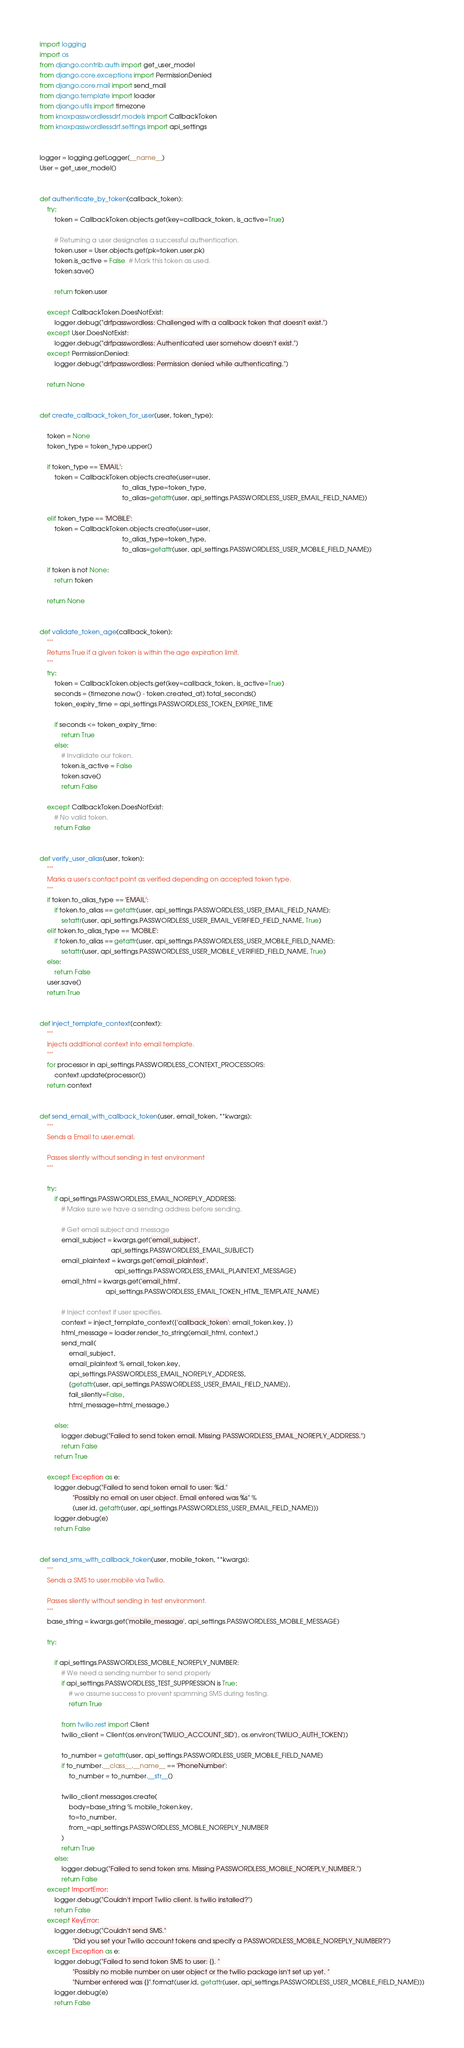Convert code to text. <code><loc_0><loc_0><loc_500><loc_500><_Python_>import logging
import os
from django.contrib.auth import get_user_model
from django.core.exceptions import PermissionDenied
from django.core.mail import send_mail
from django.template import loader
from django.utils import timezone
from knoxpasswordlessdrf.models import CallbackToken
from knoxpasswordlessdrf.settings import api_settings


logger = logging.getLogger(__name__)
User = get_user_model()


def authenticate_by_token(callback_token):
    try:
        token = CallbackToken.objects.get(key=callback_token, is_active=True)

        # Returning a user designates a successful authentication.
        token.user = User.objects.get(pk=token.user.pk)
        token.is_active = False  # Mark this token as used.
        token.save()

        return token.user

    except CallbackToken.DoesNotExist:
        logger.debug("drfpasswordless: Challenged with a callback token that doesn't exist.")
    except User.DoesNotExist:
        logger.debug("drfpasswordless: Authenticated user somehow doesn't exist.")
    except PermissionDenied:
        logger.debug("drfpasswordless: Permission denied while authenticating.")

    return None


def create_callback_token_for_user(user, token_type):

    token = None
    token_type = token_type.upper()

    if token_type == 'EMAIL':
        token = CallbackToken.objects.create(user=user,
                                             to_alias_type=token_type,
                                             to_alias=getattr(user, api_settings.PASSWORDLESS_USER_EMAIL_FIELD_NAME))

    elif token_type == 'MOBILE':
        token = CallbackToken.objects.create(user=user,
                                             to_alias_type=token_type,
                                             to_alias=getattr(user, api_settings.PASSWORDLESS_USER_MOBILE_FIELD_NAME))

    if token is not None:
        return token

    return None


def validate_token_age(callback_token):
    """
    Returns True if a given token is within the age expiration limit.
    """
    try:
        token = CallbackToken.objects.get(key=callback_token, is_active=True)
        seconds = (timezone.now() - token.created_at).total_seconds()
        token_expiry_time = api_settings.PASSWORDLESS_TOKEN_EXPIRE_TIME

        if seconds <= token_expiry_time:
            return True
        else:
            # Invalidate our token.
            token.is_active = False
            token.save()
            return False

    except CallbackToken.DoesNotExist:
        # No valid token.
        return False


def verify_user_alias(user, token):
    """
    Marks a user's contact point as verified depending on accepted token type.
    """
    if token.to_alias_type == 'EMAIL':
        if token.to_alias == getattr(user, api_settings.PASSWORDLESS_USER_EMAIL_FIELD_NAME):
            setattr(user, api_settings.PASSWORDLESS_USER_EMAIL_VERIFIED_FIELD_NAME, True)
    elif token.to_alias_type == 'MOBILE':
        if token.to_alias == getattr(user, api_settings.PASSWORDLESS_USER_MOBILE_FIELD_NAME):
            setattr(user, api_settings.PASSWORDLESS_USER_MOBILE_VERIFIED_FIELD_NAME, True)
    else:
        return False
    user.save()
    return True


def inject_template_context(context):
    """
    Injects additional context into email template.
    """
    for processor in api_settings.PASSWORDLESS_CONTEXT_PROCESSORS:
        context.update(processor())
    return context


def send_email_with_callback_token(user, email_token, **kwargs):
    """
    Sends a Email to user.email.

    Passes silently without sending in test environment
    """

    try:
        if api_settings.PASSWORDLESS_EMAIL_NOREPLY_ADDRESS:
            # Make sure we have a sending address before sending.

            # Get email subject and message
            email_subject = kwargs.get('email_subject',
                                       api_settings.PASSWORDLESS_EMAIL_SUBJECT)
            email_plaintext = kwargs.get('email_plaintext',
                                         api_settings.PASSWORDLESS_EMAIL_PLAINTEXT_MESSAGE)
            email_html = kwargs.get('email_html',
                                    api_settings.PASSWORDLESS_EMAIL_TOKEN_HTML_TEMPLATE_NAME)

            # Inject context if user specifies.
            context = inject_template_context({'callback_token': email_token.key, })
            html_message = loader.render_to_string(email_html, context,)
            send_mail(
                email_subject,
                email_plaintext % email_token.key,
                api_settings.PASSWORDLESS_EMAIL_NOREPLY_ADDRESS,
                [getattr(user, api_settings.PASSWORDLESS_USER_EMAIL_FIELD_NAME)],
                fail_silently=False,
                html_message=html_message,)

        else:
            logger.debug("Failed to send token email. Missing PASSWORDLESS_EMAIL_NOREPLY_ADDRESS.")
            return False
        return True

    except Exception as e:
        logger.debug("Failed to send token email to user: %d."
                  "Possibly no email on user object. Email entered was %s" %
                  (user.id, getattr(user, api_settings.PASSWORDLESS_USER_EMAIL_FIELD_NAME)))
        logger.debug(e)
        return False


def send_sms_with_callback_token(user, mobile_token, **kwargs):
    """
    Sends a SMS to user.mobile via Twilio.

    Passes silently without sending in test environment.
    """
    base_string = kwargs.get('mobile_message', api_settings.PASSWORDLESS_MOBILE_MESSAGE)

    try:

        if api_settings.PASSWORDLESS_MOBILE_NOREPLY_NUMBER:
            # We need a sending number to send properly
            if api_settings.PASSWORDLESS_TEST_SUPPRESSION is True:
                # we assume success to prevent spamming SMS during testing.
                return True

            from twilio.rest import Client
            twilio_client = Client(os.environ['TWILIO_ACCOUNT_SID'], os.environ['TWILIO_AUTH_TOKEN'])

            to_number = getattr(user, api_settings.PASSWORDLESS_USER_MOBILE_FIELD_NAME)
            if to_number.__class__.__name__ == 'PhoneNumber':
                to_number = to_number.__str__()

            twilio_client.messages.create(
                body=base_string % mobile_token.key,
                to=to_number,
                from_=api_settings.PASSWORDLESS_MOBILE_NOREPLY_NUMBER
            )
            return True
        else:
            logger.debug("Failed to send token sms. Missing PASSWORDLESS_MOBILE_NOREPLY_NUMBER.")
            return False
    except ImportError:
        logger.debug("Couldn't import Twilio client. Is twilio installed?")
        return False
    except KeyError:
        logger.debug("Couldn't send SMS."
                  "Did you set your Twilio account tokens and specify a PASSWORDLESS_MOBILE_NOREPLY_NUMBER?")
    except Exception as e:
        logger.debug("Failed to send token SMS to user: {}. "
                  "Possibly no mobile number on user object or the twilio package isn't set up yet. "
                  "Number entered was {}".format(user.id, getattr(user, api_settings.PASSWORDLESS_USER_MOBILE_FIELD_NAME)))
        logger.debug(e)
        return False
</code> 